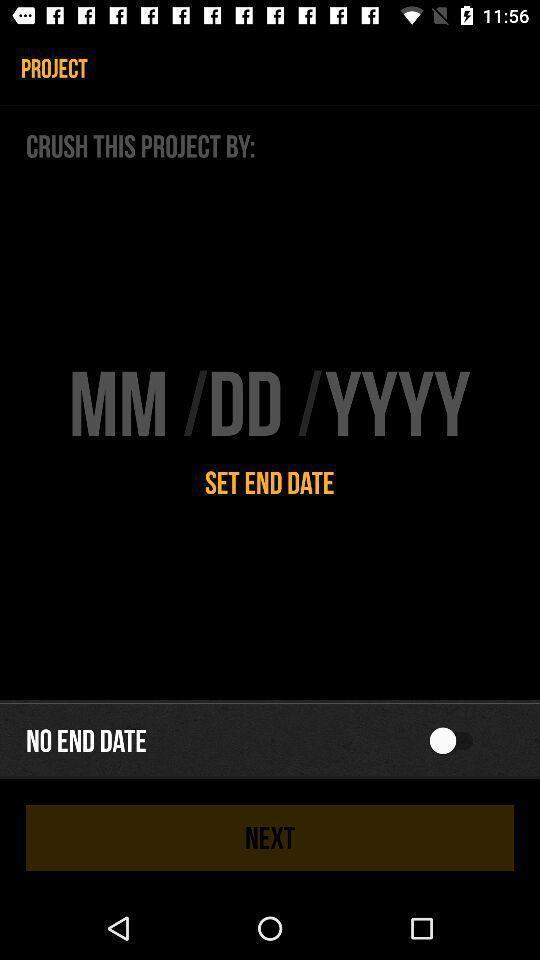Please provide a description for this image. Page displaying to set the date month and year. 